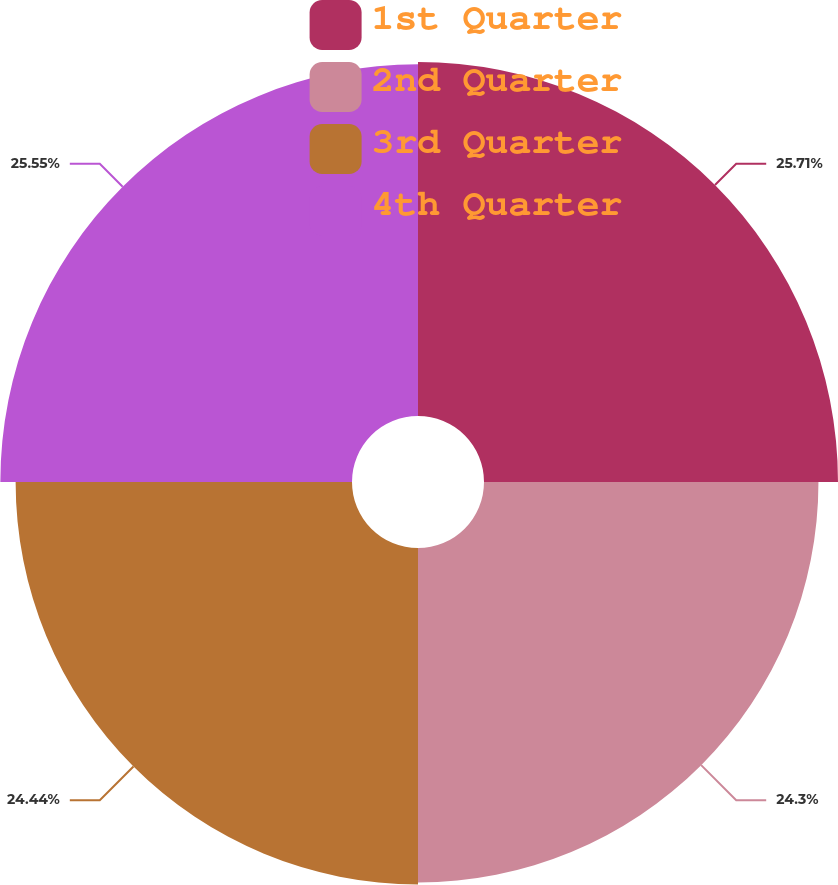<chart> <loc_0><loc_0><loc_500><loc_500><pie_chart><fcel>1st Quarter<fcel>2nd Quarter<fcel>3rd Quarter<fcel>4th Quarter<nl><fcel>25.72%<fcel>24.3%<fcel>24.44%<fcel>25.55%<nl></chart> 